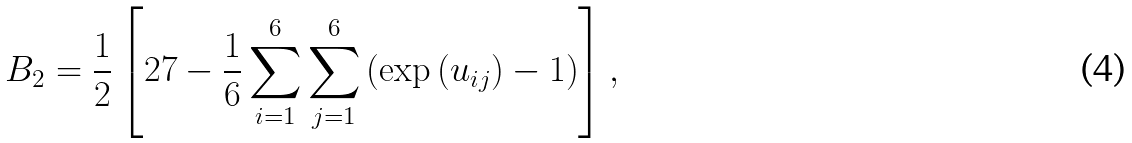<formula> <loc_0><loc_0><loc_500><loc_500>B _ { 2 } = \frac { 1 } { 2 } \left [ 2 7 - \frac { 1 } { 6 } \sum _ { i = 1 } ^ { 6 } \sum _ { j = 1 } ^ { 6 } \left ( \exp \left ( u _ { i j } \right ) - 1 \right ) \right ] ,</formula> 